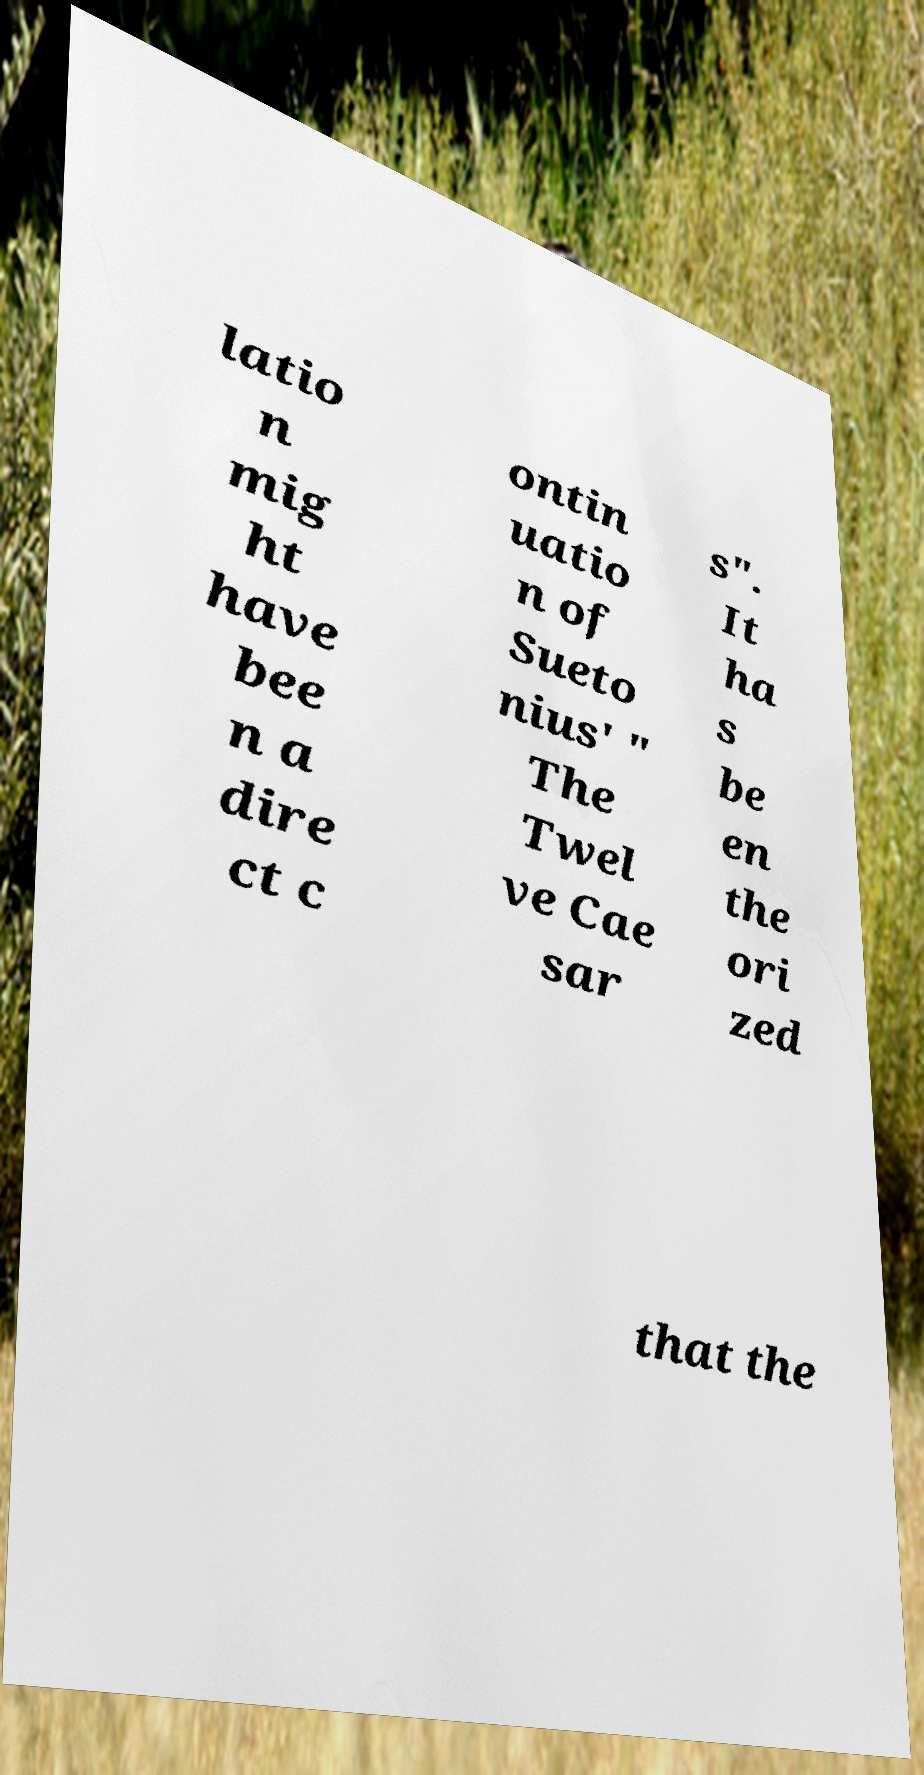Please read and relay the text visible in this image. What does it say? latio n mig ht have bee n a dire ct c ontin uatio n of Sueto nius' " The Twel ve Cae sar s". It ha s be en the ori zed that the 